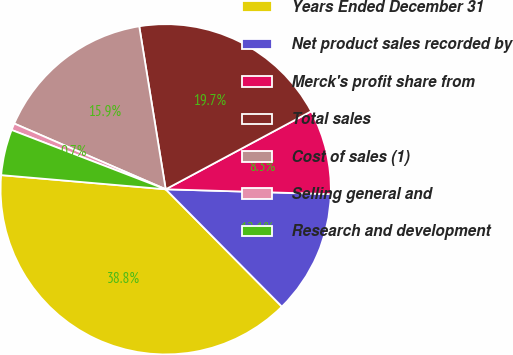Convert chart. <chart><loc_0><loc_0><loc_500><loc_500><pie_chart><fcel>Years Ended December 31<fcel>Net product sales recorded by<fcel>Merck's profit share from<fcel>Total sales<fcel>Cost of sales (1)<fcel>Selling general and<fcel>Research and development<nl><fcel>38.79%<fcel>12.11%<fcel>8.3%<fcel>19.73%<fcel>15.92%<fcel>0.67%<fcel>4.48%<nl></chart> 